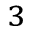Convert formula to latex. <formula><loc_0><loc_0><loc_500><loc_500>^ { 3 }</formula> 